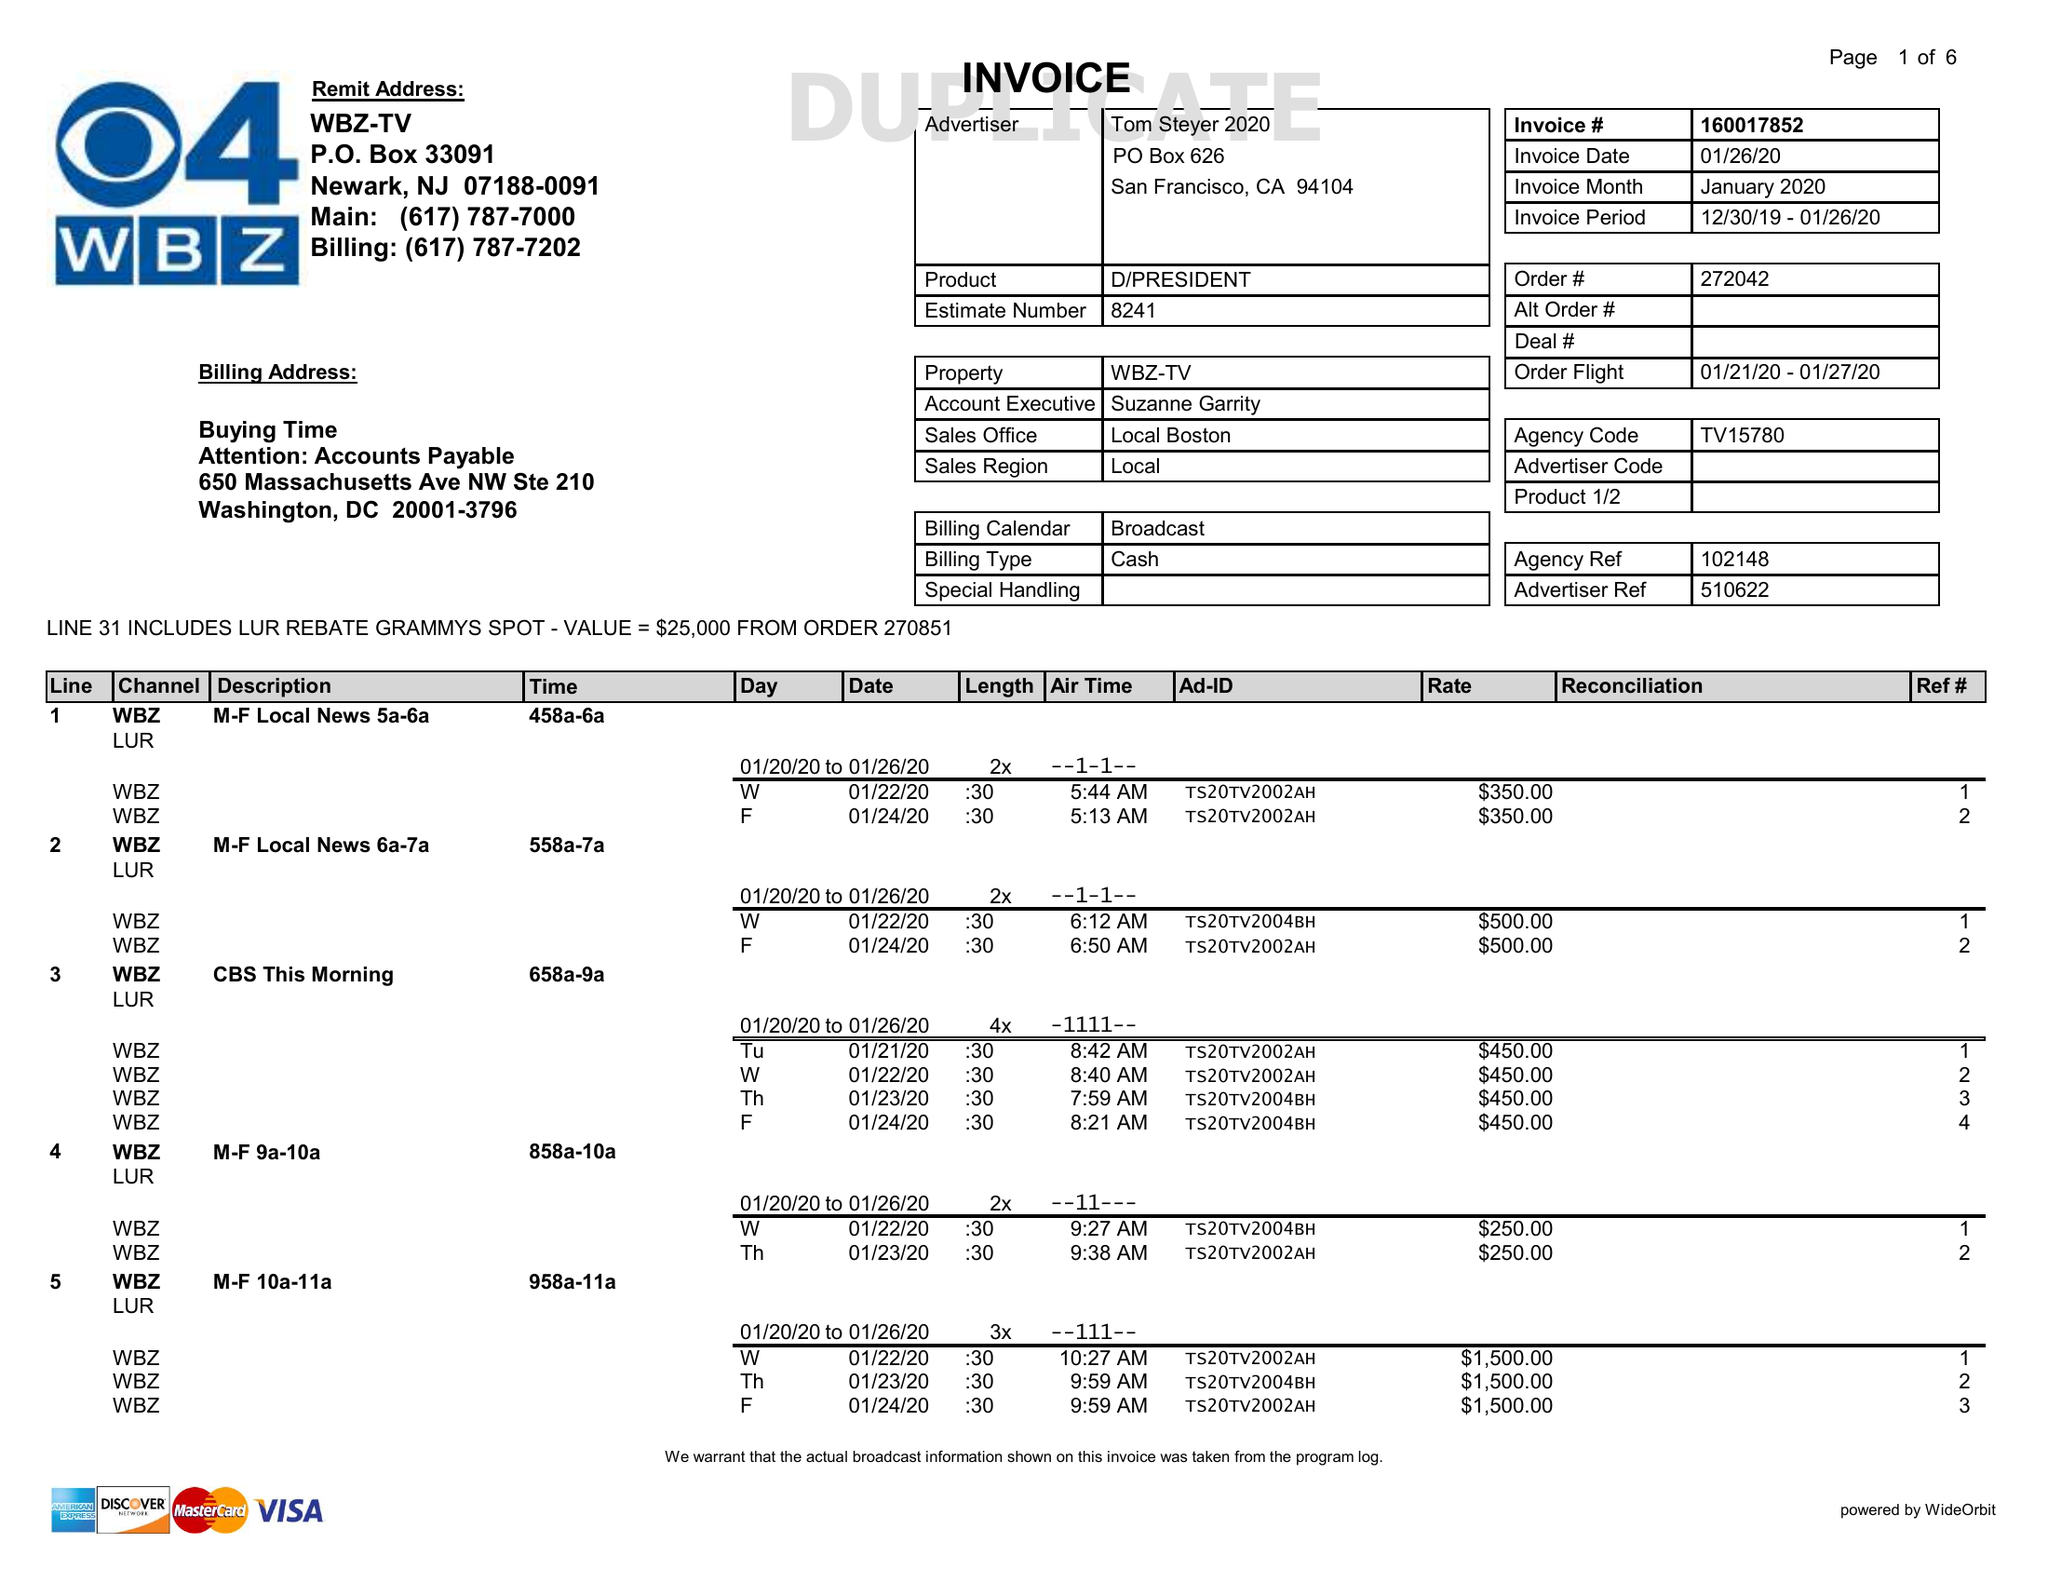What is the value for the flight_from?
Answer the question using a single word or phrase. 01/21/20 